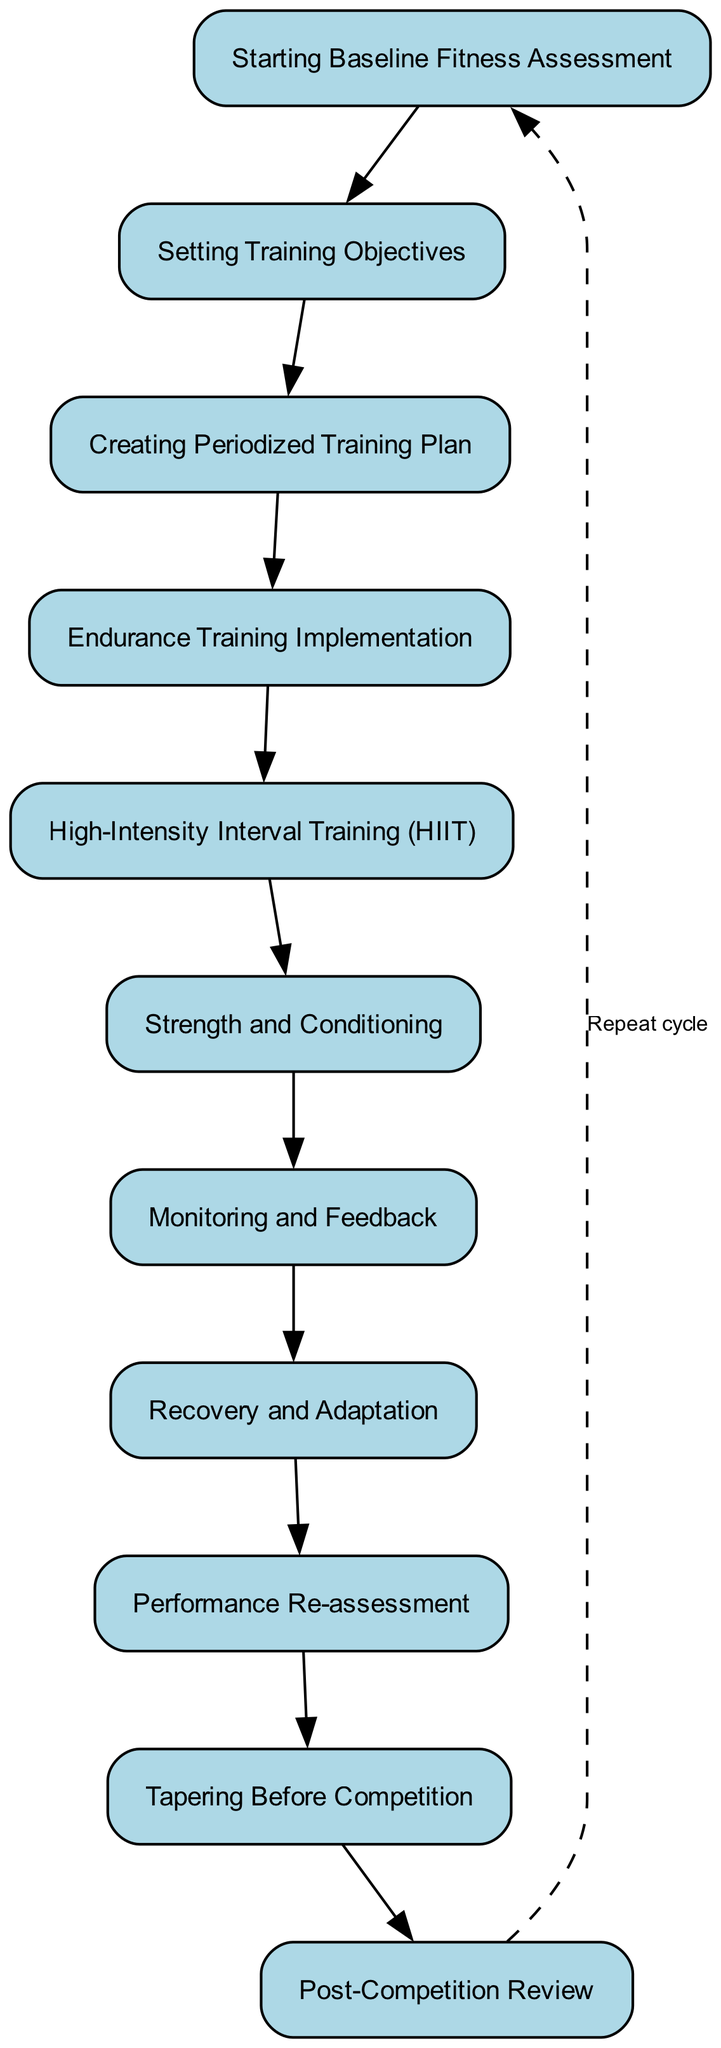What is the first activity in the diagram? The first activity in the flow of the diagram is labeled "Starting Baseline Fitness Assessment." It is the top-most node, representing the start of the training methodology.
Answer: Starting Baseline Fitness Assessment How many total activities are in the diagram? By counting the nodes listed in the diagram, there are ten distinct activities that Lance Armstrong follows in his training methodology.
Answer: 10 What is the last activity listed in the diagram? The last activity in the progression of the diagram is "Post-Competition Review," which is positioned at the end of the sequence of activities.
Answer: Post-Competition Review What activity follows "Endurance Training Implementation"? The diagram indicates that "High-Intensity Interval Training (HIIT)" directly follows "Endurance Training Implementation," showcasing the sequence of training methods.
Answer: High-Intensity Interval Training (HIIT) What happens after "Performance Re-assessment"? According to the diagram, after "Performance Re-assessment," the next step is "Tapering Before Competition," indicating a progression toward race day preparation.
Answer: Tapering Before Competition How many edges connect the activities in the diagram? The connections between the activities can be quantified by noting that each node (except the first) has an incoming edge from the prior node, and there is one additional dashed edge connecting the last activity back to the first. Thus, there are eleven edges in total.
Answer: 11 What is the relationship between "Recovery and Adaptation" and "Monitoring and Feedback"? In the sequence of activities, "Monitoring and Feedback" occurs before "Recovery and Adaptation," indicating that monitoring performance is essential for tailoring recovery strategies to maintain optimal training progress.
Answer: Monitoring and Feedback occurs before Recovery and Adaptation Which activities focus on performance improvement? The activities that concentrate on enhancing performance are "Endurance Training Implementation," "High-Intensity Interval Training (HIIT)," "Strength and Conditioning," and "Monitoring and Feedback," as they are designed to boost specific physical capabilities and track progress.
Answer: Endurance Training Implementation, High-Intensity Interval Training (HIIT), Strength and Conditioning, Monitoring and Feedback What indicates the cycle in the diagram? The dashed edge leading from "Post-Competition Review" back to "Starting Baseline Fitness Assessment" signifies the cyclical nature of the training process, emphasizing the continuous progression and reassessment integral to Lance Armstrong's methodology.
Answer: Dashed edge indicating repeat cycle 